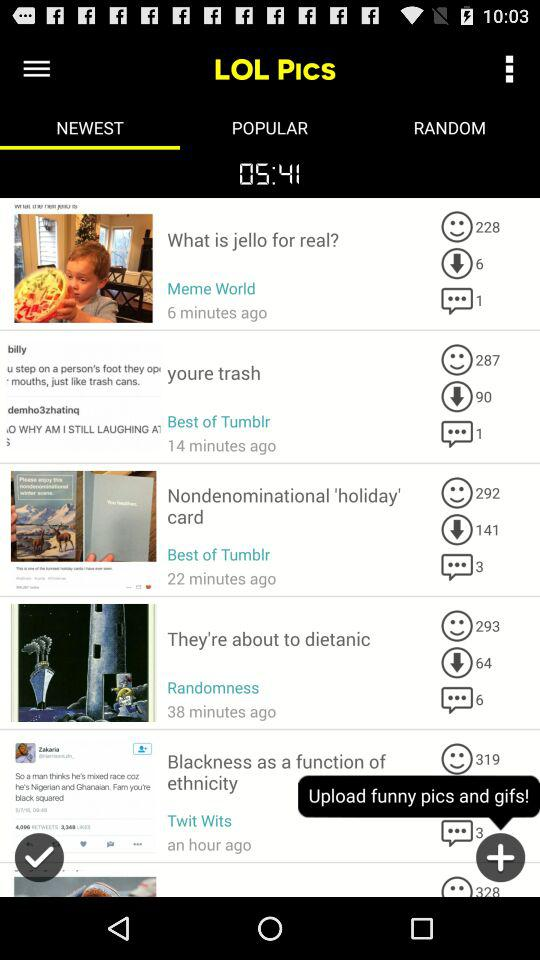How many likes did your trash post receive?
When the provided information is insufficient, respond with <no answer>. <no answer> 